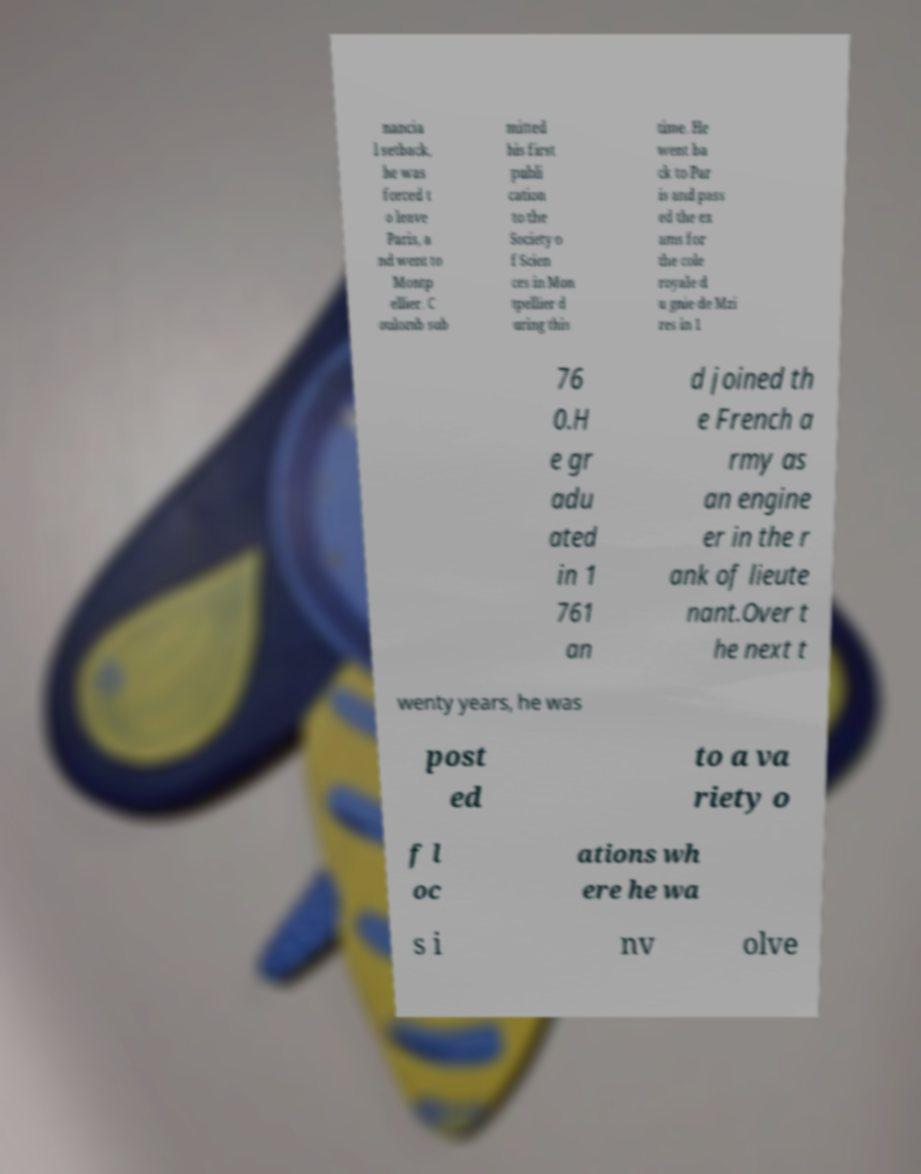I need the written content from this picture converted into text. Can you do that? nancia l setback, he was forced t o leave Paris, a nd went to Montp ellier. C oulomb sub mitted his first publi cation to the Society o f Scien ces in Mon tpellier d uring this time. He went ba ck to Par is and pass ed the ex ams for the cole royale d u gnie de Mzi res in 1 76 0.H e gr adu ated in 1 761 an d joined th e French a rmy as an engine er in the r ank of lieute nant.Over t he next t wenty years, he was post ed to a va riety o f l oc ations wh ere he wa s i nv olve 